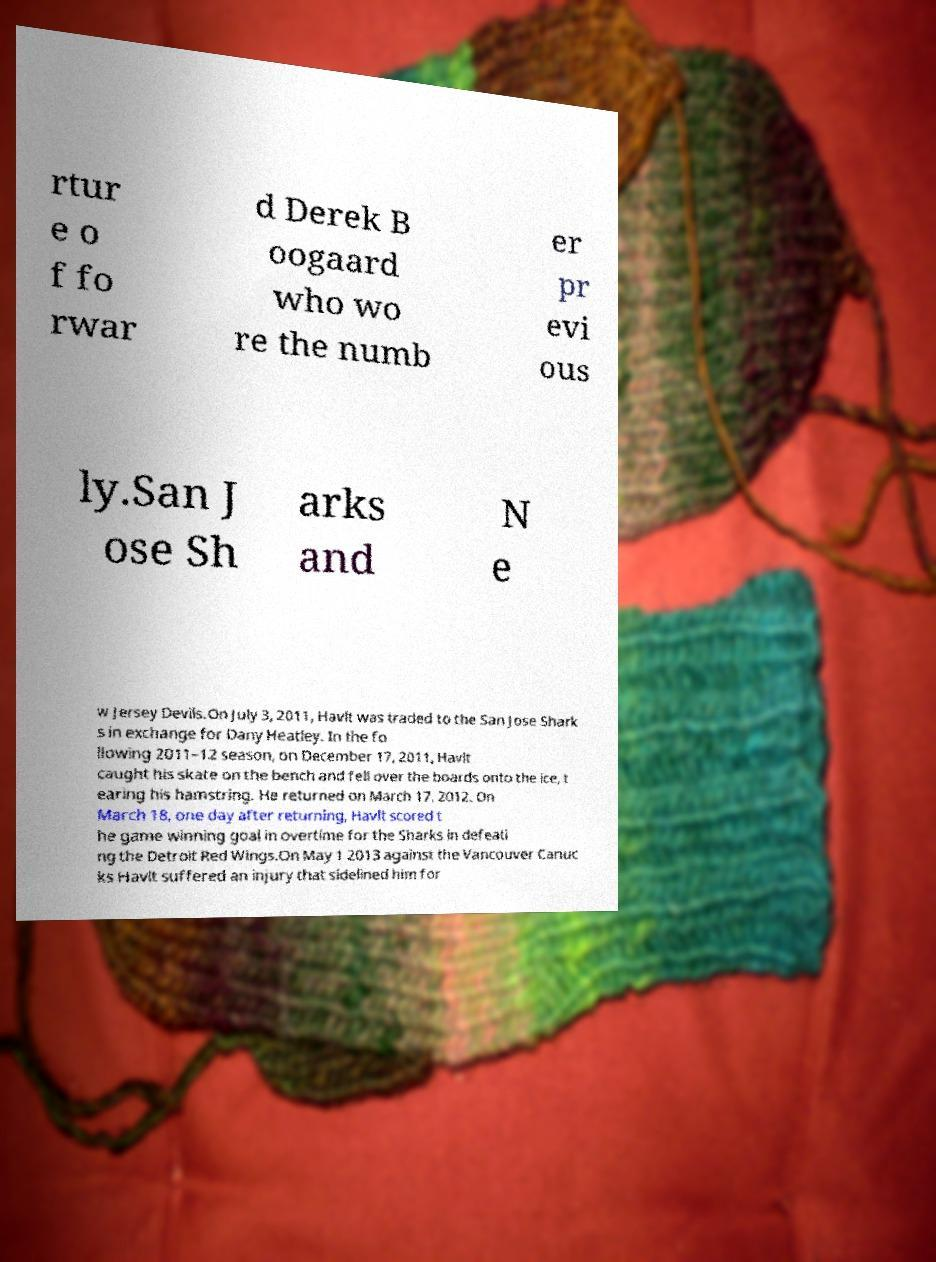Please identify and transcribe the text found in this image. rtur e o f fo rwar d Derek B oogaard who wo re the numb er pr evi ous ly.San J ose Sh arks and N e w Jersey Devils.On July 3, 2011, Havlt was traded to the San Jose Shark s in exchange for Dany Heatley. In the fo llowing 2011–12 season, on December 17, 2011, Havlt caught his skate on the bench and fell over the boards onto the ice, t earing his hamstring. He returned on March 17, 2012. On March 18, one day after returning, Havlt scored t he game winning goal in overtime for the Sharks in defeati ng the Detroit Red Wings.On May 1 2013 against the Vancouver Canuc ks Havlt suffered an injury that sidelined him for 